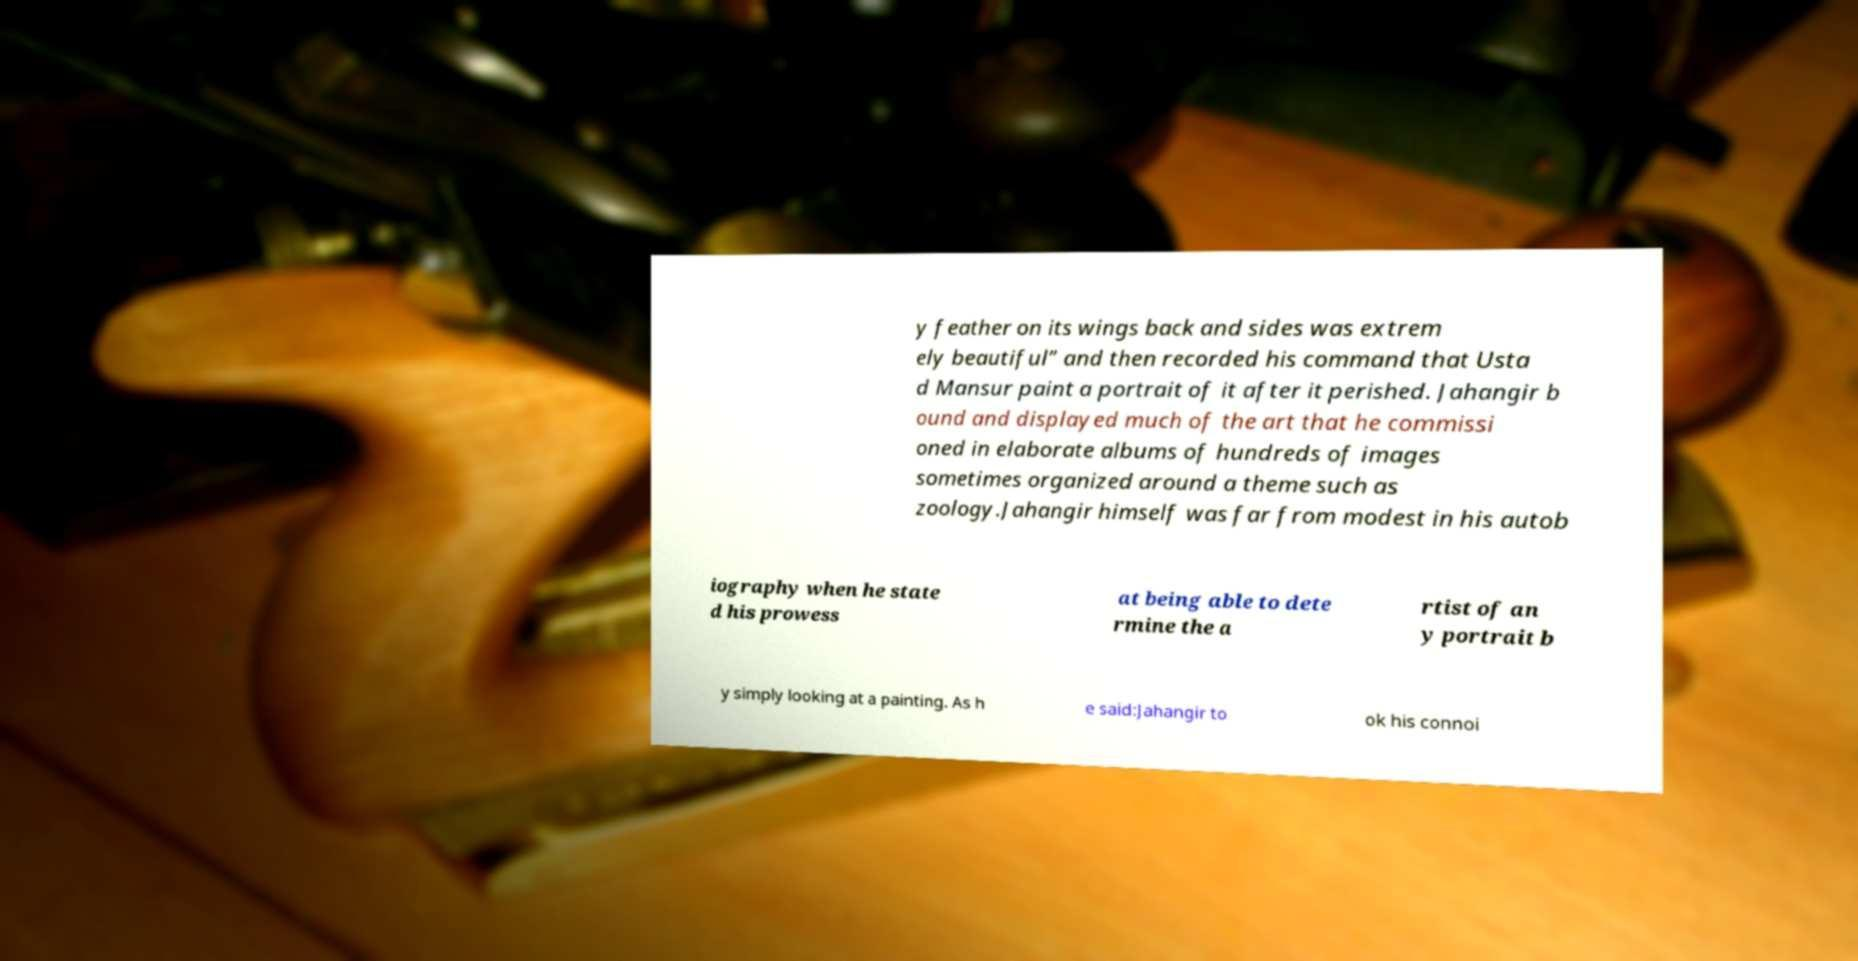Please read and relay the text visible in this image. What does it say? y feather on its wings back and sides was extrem ely beautiful” and then recorded his command that Usta d Mansur paint a portrait of it after it perished. Jahangir b ound and displayed much of the art that he commissi oned in elaborate albums of hundreds of images sometimes organized around a theme such as zoology.Jahangir himself was far from modest in his autob iography when he state d his prowess at being able to dete rmine the a rtist of an y portrait b y simply looking at a painting. As h e said:Jahangir to ok his connoi 